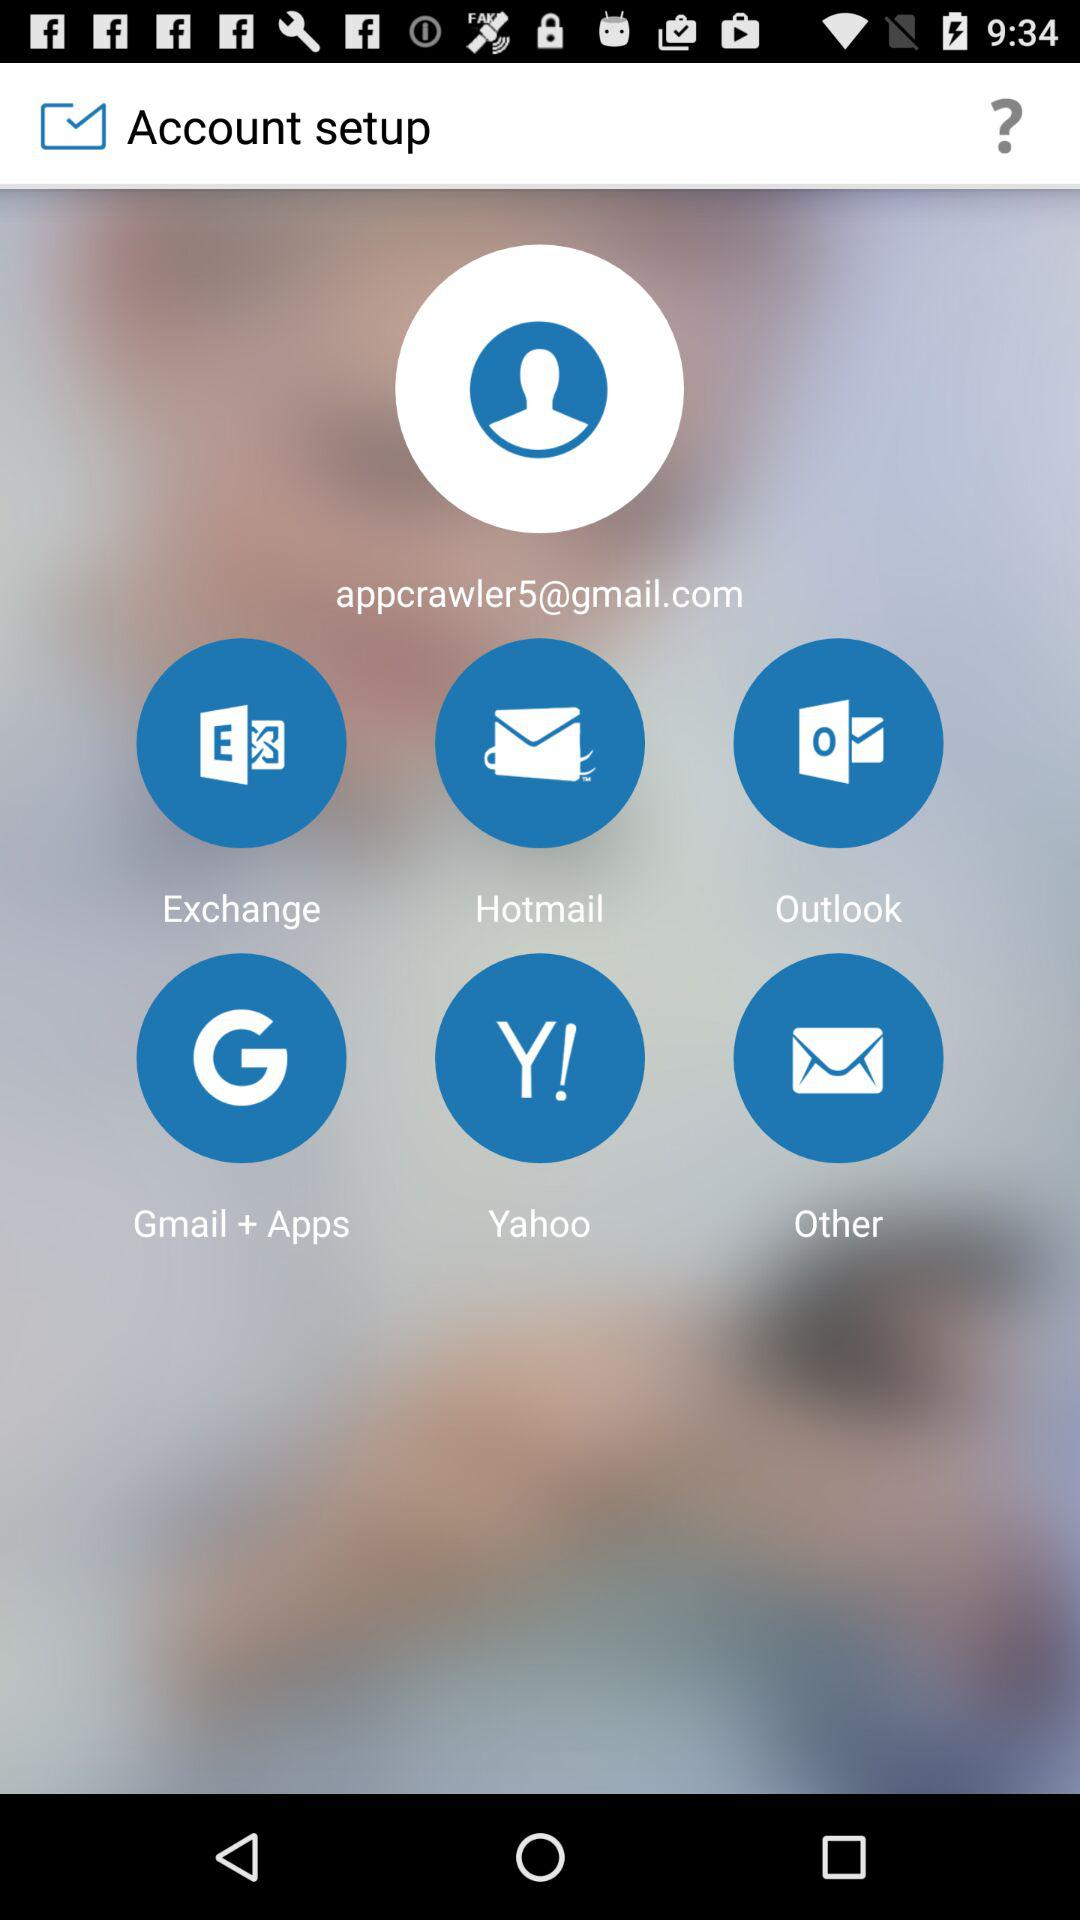How many emails are there in "Outlook"?
When the provided information is insufficient, respond with <no answer>. <no answer> 